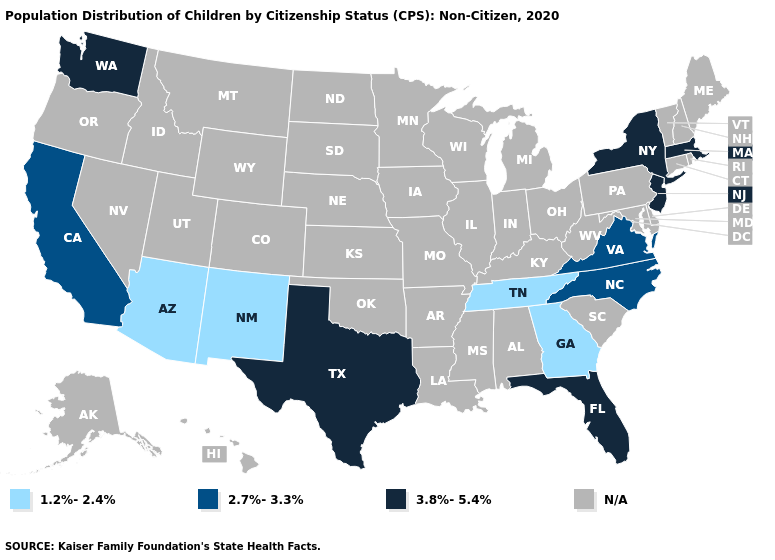Name the states that have a value in the range 2.7%-3.3%?
Keep it brief. California, North Carolina, Virginia. What is the lowest value in the USA?
Short answer required. 1.2%-2.4%. What is the value of Florida?
Quick response, please. 3.8%-5.4%. What is the value of New York?
Write a very short answer. 3.8%-5.4%. What is the value of Missouri?
Write a very short answer. N/A. Name the states that have a value in the range 1.2%-2.4%?
Be succinct. Arizona, Georgia, New Mexico, Tennessee. Does the first symbol in the legend represent the smallest category?
Answer briefly. Yes. Name the states that have a value in the range 2.7%-3.3%?
Answer briefly. California, North Carolina, Virginia. What is the value of Florida?
Be succinct. 3.8%-5.4%. What is the value of Nevada?
Keep it brief. N/A. Name the states that have a value in the range 2.7%-3.3%?
Be succinct. California, North Carolina, Virginia. Does the map have missing data?
Give a very brief answer. Yes. Does the first symbol in the legend represent the smallest category?
Quick response, please. Yes. 